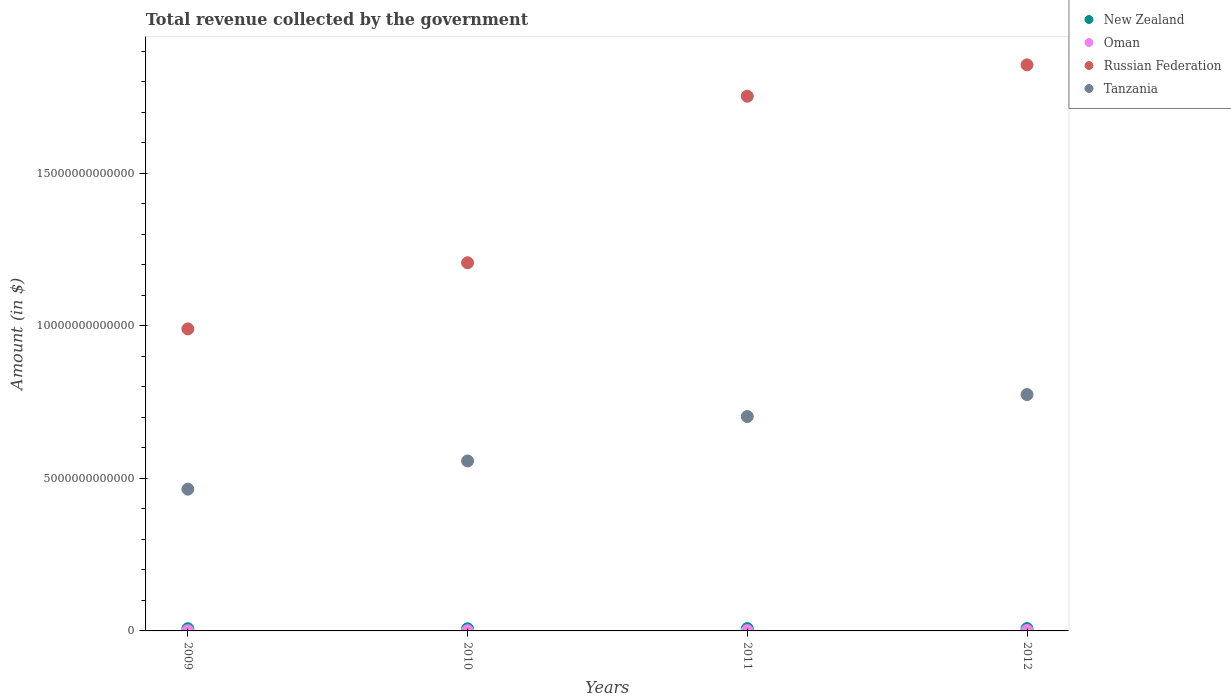What is the total revenue collected by the government in Oman in 2009?
Give a very brief answer. 6.71e+09. Across all years, what is the maximum total revenue collected by the government in Oman?
Give a very brief answer. 1.34e+1. Across all years, what is the minimum total revenue collected by the government in Tanzania?
Keep it short and to the point. 4.65e+12. In which year was the total revenue collected by the government in Oman minimum?
Your answer should be very brief. 2009. What is the total total revenue collected by the government in Oman in the graph?
Your answer should be compact. 3.86e+1. What is the difference between the total revenue collected by the government in Tanzania in 2009 and that in 2010?
Your response must be concise. -9.25e+11. What is the difference between the total revenue collected by the government in Oman in 2011 and the total revenue collected by the government in Russian Federation in 2009?
Keep it short and to the point. -9.89e+12. What is the average total revenue collected by the government in New Zealand per year?
Keep it short and to the point. 7.36e+1. In the year 2011, what is the difference between the total revenue collected by the government in Russian Federation and total revenue collected by the government in Tanzania?
Offer a terse response. 1.05e+13. What is the ratio of the total revenue collected by the government in Russian Federation in 2010 to that in 2011?
Ensure brevity in your answer.  0.69. Is the total revenue collected by the government in Russian Federation in 2011 less than that in 2012?
Provide a short and direct response. Yes. What is the difference between the highest and the second highest total revenue collected by the government in Tanzania?
Your answer should be compact. 7.20e+11. What is the difference between the highest and the lowest total revenue collected by the government in Russian Federation?
Make the answer very short. 8.65e+12. In how many years, is the total revenue collected by the government in New Zealand greater than the average total revenue collected by the government in New Zealand taken over all years?
Your answer should be very brief. 2. Is the sum of the total revenue collected by the government in Russian Federation in 2009 and 2011 greater than the maximum total revenue collected by the government in Oman across all years?
Your answer should be very brief. Yes. Is the total revenue collected by the government in Oman strictly greater than the total revenue collected by the government in Tanzania over the years?
Your answer should be very brief. No. Is the total revenue collected by the government in Tanzania strictly less than the total revenue collected by the government in Russian Federation over the years?
Give a very brief answer. Yes. How many dotlines are there?
Keep it short and to the point. 4. How many years are there in the graph?
Provide a succinct answer. 4. What is the difference between two consecutive major ticks on the Y-axis?
Ensure brevity in your answer.  5.00e+12. Does the graph contain grids?
Your response must be concise. No. What is the title of the graph?
Your answer should be very brief. Total revenue collected by the government. Does "Guinea" appear as one of the legend labels in the graph?
Give a very brief answer. No. What is the label or title of the Y-axis?
Keep it short and to the point. Amount (in $). What is the Amount (in $) in New Zealand in 2009?
Your response must be concise. 7.20e+1. What is the Amount (in $) in Oman in 2009?
Your answer should be compact. 6.71e+09. What is the Amount (in $) in Russian Federation in 2009?
Provide a short and direct response. 9.90e+12. What is the Amount (in $) of Tanzania in 2009?
Your response must be concise. 4.65e+12. What is the Amount (in $) of New Zealand in 2010?
Provide a short and direct response. 6.99e+1. What is the Amount (in $) of Oman in 2010?
Your answer should be compact. 7.87e+09. What is the Amount (in $) in Russian Federation in 2010?
Provide a short and direct response. 1.21e+13. What is the Amount (in $) of Tanzania in 2010?
Your answer should be compact. 5.57e+12. What is the Amount (in $) of New Zealand in 2011?
Give a very brief answer. 7.61e+1. What is the Amount (in $) of Oman in 2011?
Ensure brevity in your answer.  1.06e+1. What is the Amount (in $) in Russian Federation in 2011?
Keep it short and to the point. 1.75e+13. What is the Amount (in $) in Tanzania in 2011?
Offer a terse response. 7.03e+12. What is the Amount (in $) of New Zealand in 2012?
Keep it short and to the point. 7.64e+1. What is the Amount (in $) in Oman in 2012?
Ensure brevity in your answer.  1.34e+1. What is the Amount (in $) of Russian Federation in 2012?
Your response must be concise. 1.85e+13. What is the Amount (in $) in Tanzania in 2012?
Provide a short and direct response. 7.75e+12. Across all years, what is the maximum Amount (in $) of New Zealand?
Your answer should be very brief. 7.64e+1. Across all years, what is the maximum Amount (in $) of Oman?
Give a very brief answer. 1.34e+1. Across all years, what is the maximum Amount (in $) in Russian Federation?
Offer a terse response. 1.85e+13. Across all years, what is the maximum Amount (in $) of Tanzania?
Provide a short and direct response. 7.75e+12. Across all years, what is the minimum Amount (in $) of New Zealand?
Make the answer very short. 6.99e+1. Across all years, what is the minimum Amount (in $) in Oman?
Keep it short and to the point. 6.71e+09. Across all years, what is the minimum Amount (in $) of Russian Federation?
Keep it short and to the point. 9.90e+12. Across all years, what is the minimum Amount (in $) in Tanzania?
Your answer should be very brief. 4.65e+12. What is the total Amount (in $) in New Zealand in the graph?
Your answer should be very brief. 2.94e+11. What is the total Amount (in $) of Oman in the graph?
Your answer should be compact. 3.86e+1. What is the total Amount (in $) of Russian Federation in the graph?
Provide a succinct answer. 5.80e+13. What is the total Amount (in $) in Tanzania in the graph?
Your response must be concise. 2.50e+13. What is the difference between the Amount (in $) in New Zealand in 2009 and that in 2010?
Your response must be concise. 2.05e+09. What is the difference between the Amount (in $) in Oman in 2009 and that in 2010?
Provide a short and direct response. -1.15e+09. What is the difference between the Amount (in $) in Russian Federation in 2009 and that in 2010?
Give a very brief answer. -2.17e+12. What is the difference between the Amount (in $) of Tanzania in 2009 and that in 2010?
Give a very brief answer. -9.25e+11. What is the difference between the Amount (in $) of New Zealand in 2009 and that in 2011?
Your response must be concise. -4.18e+09. What is the difference between the Amount (in $) in Oman in 2009 and that in 2011?
Provide a short and direct response. -3.85e+09. What is the difference between the Amount (in $) of Russian Federation in 2009 and that in 2011?
Provide a succinct answer. -7.62e+12. What is the difference between the Amount (in $) in Tanzania in 2009 and that in 2011?
Your answer should be compact. -2.38e+12. What is the difference between the Amount (in $) in New Zealand in 2009 and that in 2012?
Give a very brief answer. -4.42e+09. What is the difference between the Amount (in $) of Oman in 2009 and that in 2012?
Give a very brief answer. -6.74e+09. What is the difference between the Amount (in $) of Russian Federation in 2009 and that in 2012?
Your answer should be compact. -8.65e+12. What is the difference between the Amount (in $) of Tanzania in 2009 and that in 2012?
Make the answer very short. -3.10e+12. What is the difference between the Amount (in $) in New Zealand in 2010 and that in 2011?
Provide a succinct answer. -6.24e+09. What is the difference between the Amount (in $) in Oman in 2010 and that in 2011?
Provide a succinct answer. -2.70e+09. What is the difference between the Amount (in $) of Russian Federation in 2010 and that in 2011?
Your response must be concise. -5.46e+12. What is the difference between the Amount (in $) in Tanzania in 2010 and that in 2011?
Your answer should be compact. -1.46e+12. What is the difference between the Amount (in $) of New Zealand in 2010 and that in 2012?
Offer a very short reply. -6.47e+09. What is the difference between the Amount (in $) of Oman in 2010 and that in 2012?
Provide a succinct answer. -5.58e+09. What is the difference between the Amount (in $) in Russian Federation in 2010 and that in 2012?
Provide a short and direct response. -6.48e+12. What is the difference between the Amount (in $) of Tanzania in 2010 and that in 2012?
Keep it short and to the point. -2.18e+12. What is the difference between the Amount (in $) in New Zealand in 2011 and that in 2012?
Provide a succinct answer. -2.32e+08. What is the difference between the Amount (in $) in Oman in 2011 and that in 2012?
Provide a short and direct response. -2.88e+09. What is the difference between the Amount (in $) of Russian Federation in 2011 and that in 2012?
Provide a succinct answer. -1.03e+12. What is the difference between the Amount (in $) in Tanzania in 2011 and that in 2012?
Offer a very short reply. -7.20e+11. What is the difference between the Amount (in $) in New Zealand in 2009 and the Amount (in $) in Oman in 2010?
Your answer should be very brief. 6.41e+1. What is the difference between the Amount (in $) of New Zealand in 2009 and the Amount (in $) of Russian Federation in 2010?
Provide a succinct answer. -1.20e+13. What is the difference between the Amount (in $) in New Zealand in 2009 and the Amount (in $) in Tanzania in 2010?
Your response must be concise. -5.50e+12. What is the difference between the Amount (in $) in Oman in 2009 and the Amount (in $) in Russian Federation in 2010?
Offer a terse response. -1.21e+13. What is the difference between the Amount (in $) of Oman in 2009 and the Amount (in $) of Tanzania in 2010?
Your answer should be compact. -5.56e+12. What is the difference between the Amount (in $) in Russian Federation in 2009 and the Amount (in $) in Tanzania in 2010?
Your response must be concise. 4.33e+12. What is the difference between the Amount (in $) of New Zealand in 2009 and the Amount (in $) of Oman in 2011?
Your answer should be compact. 6.14e+1. What is the difference between the Amount (in $) in New Zealand in 2009 and the Amount (in $) in Russian Federation in 2011?
Your answer should be compact. -1.75e+13. What is the difference between the Amount (in $) of New Zealand in 2009 and the Amount (in $) of Tanzania in 2011?
Keep it short and to the point. -6.95e+12. What is the difference between the Amount (in $) of Oman in 2009 and the Amount (in $) of Russian Federation in 2011?
Your answer should be compact. -1.75e+13. What is the difference between the Amount (in $) in Oman in 2009 and the Amount (in $) in Tanzania in 2011?
Make the answer very short. -7.02e+12. What is the difference between the Amount (in $) of Russian Federation in 2009 and the Amount (in $) of Tanzania in 2011?
Keep it short and to the point. 2.87e+12. What is the difference between the Amount (in $) of New Zealand in 2009 and the Amount (in $) of Oman in 2012?
Your response must be concise. 5.85e+1. What is the difference between the Amount (in $) of New Zealand in 2009 and the Amount (in $) of Russian Federation in 2012?
Offer a very short reply. -1.85e+13. What is the difference between the Amount (in $) of New Zealand in 2009 and the Amount (in $) of Tanzania in 2012?
Your answer should be compact. -7.67e+12. What is the difference between the Amount (in $) in Oman in 2009 and the Amount (in $) in Russian Federation in 2012?
Provide a succinct answer. -1.85e+13. What is the difference between the Amount (in $) of Oman in 2009 and the Amount (in $) of Tanzania in 2012?
Keep it short and to the point. -7.74e+12. What is the difference between the Amount (in $) of Russian Federation in 2009 and the Amount (in $) of Tanzania in 2012?
Offer a very short reply. 2.15e+12. What is the difference between the Amount (in $) in New Zealand in 2010 and the Amount (in $) in Oman in 2011?
Your answer should be very brief. 5.93e+1. What is the difference between the Amount (in $) of New Zealand in 2010 and the Amount (in $) of Russian Federation in 2011?
Make the answer very short. -1.75e+13. What is the difference between the Amount (in $) in New Zealand in 2010 and the Amount (in $) in Tanzania in 2011?
Offer a very short reply. -6.96e+12. What is the difference between the Amount (in $) of Oman in 2010 and the Amount (in $) of Russian Federation in 2011?
Keep it short and to the point. -1.75e+13. What is the difference between the Amount (in $) of Oman in 2010 and the Amount (in $) of Tanzania in 2011?
Provide a succinct answer. -7.02e+12. What is the difference between the Amount (in $) of Russian Federation in 2010 and the Amount (in $) of Tanzania in 2011?
Give a very brief answer. 5.04e+12. What is the difference between the Amount (in $) of New Zealand in 2010 and the Amount (in $) of Oman in 2012?
Make the answer very short. 5.64e+1. What is the difference between the Amount (in $) in New Zealand in 2010 and the Amount (in $) in Russian Federation in 2012?
Offer a terse response. -1.85e+13. What is the difference between the Amount (in $) in New Zealand in 2010 and the Amount (in $) in Tanzania in 2012?
Offer a terse response. -7.68e+12. What is the difference between the Amount (in $) of Oman in 2010 and the Amount (in $) of Russian Federation in 2012?
Your response must be concise. -1.85e+13. What is the difference between the Amount (in $) in Oman in 2010 and the Amount (in $) in Tanzania in 2012?
Offer a terse response. -7.74e+12. What is the difference between the Amount (in $) in Russian Federation in 2010 and the Amount (in $) in Tanzania in 2012?
Make the answer very short. 4.32e+12. What is the difference between the Amount (in $) in New Zealand in 2011 and the Amount (in $) in Oman in 2012?
Your answer should be compact. 6.27e+1. What is the difference between the Amount (in $) in New Zealand in 2011 and the Amount (in $) in Russian Federation in 2012?
Make the answer very short. -1.85e+13. What is the difference between the Amount (in $) of New Zealand in 2011 and the Amount (in $) of Tanzania in 2012?
Your answer should be very brief. -7.67e+12. What is the difference between the Amount (in $) in Oman in 2011 and the Amount (in $) in Russian Federation in 2012?
Your answer should be very brief. -1.85e+13. What is the difference between the Amount (in $) in Oman in 2011 and the Amount (in $) in Tanzania in 2012?
Your response must be concise. -7.74e+12. What is the difference between the Amount (in $) in Russian Federation in 2011 and the Amount (in $) in Tanzania in 2012?
Make the answer very short. 9.78e+12. What is the average Amount (in $) in New Zealand per year?
Keep it short and to the point. 7.36e+1. What is the average Amount (in $) in Oman per year?
Provide a succinct answer. 9.65e+09. What is the average Amount (in $) of Russian Federation per year?
Make the answer very short. 1.45e+13. What is the average Amount (in $) in Tanzania per year?
Provide a succinct answer. 6.25e+12. In the year 2009, what is the difference between the Amount (in $) of New Zealand and Amount (in $) of Oman?
Your answer should be compact. 6.52e+1. In the year 2009, what is the difference between the Amount (in $) of New Zealand and Amount (in $) of Russian Federation?
Provide a short and direct response. -9.83e+12. In the year 2009, what is the difference between the Amount (in $) in New Zealand and Amount (in $) in Tanzania?
Your response must be concise. -4.57e+12. In the year 2009, what is the difference between the Amount (in $) of Oman and Amount (in $) of Russian Federation?
Keep it short and to the point. -9.89e+12. In the year 2009, what is the difference between the Amount (in $) of Oman and Amount (in $) of Tanzania?
Your response must be concise. -4.64e+12. In the year 2009, what is the difference between the Amount (in $) in Russian Federation and Amount (in $) in Tanzania?
Your response must be concise. 5.25e+12. In the year 2010, what is the difference between the Amount (in $) in New Zealand and Amount (in $) in Oman?
Your answer should be compact. 6.20e+1. In the year 2010, what is the difference between the Amount (in $) in New Zealand and Amount (in $) in Russian Federation?
Offer a terse response. -1.20e+13. In the year 2010, what is the difference between the Amount (in $) in New Zealand and Amount (in $) in Tanzania?
Your response must be concise. -5.50e+12. In the year 2010, what is the difference between the Amount (in $) of Oman and Amount (in $) of Russian Federation?
Your response must be concise. -1.21e+13. In the year 2010, what is the difference between the Amount (in $) in Oman and Amount (in $) in Tanzania?
Provide a short and direct response. -5.56e+12. In the year 2010, what is the difference between the Amount (in $) of Russian Federation and Amount (in $) of Tanzania?
Provide a short and direct response. 6.49e+12. In the year 2011, what is the difference between the Amount (in $) in New Zealand and Amount (in $) in Oman?
Make the answer very short. 6.56e+1. In the year 2011, what is the difference between the Amount (in $) of New Zealand and Amount (in $) of Russian Federation?
Offer a terse response. -1.74e+13. In the year 2011, what is the difference between the Amount (in $) of New Zealand and Amount (in $) of Tanzania?
Give a very brief answer. -6.95e+12. In the year 2011, what is the difference between the Amount (in $) in Oman and Amount (in $) in Russian Federation?
Your answer should be compact. -1.75e+13. In the year 2011, what is the difference between the Amount (in $) of Oman and Amount (in $) of Tanzania?
Give a very brief answer. -7.02e+12. In the year 2011, what is the difference between the Amount (in $) of Russian Federation and Amount (in $) of Tanzania?
Ensure brevity in your answer.  1.05e+13. In the year 2012, what is the difference between the Amount (in $) in New Zealand and Amount (in $) in Oman?
Give a very brief answer. 6.29e+1. In the year 2012, what is the difference between the Amount (in $) in New Zealand and Amount (in $) in Russian Federation?
Offer a terse response. -1.85e+13. In the year 2012, what is the difference between the Amount (in $) in New Zealand and Amount (in $) in Tanzania?
Offer a very short reply. -7.67e+12. In the year 2012, what is the difference between the Amount (in $) of Oman and Amount (in $) of Russian Federation?
Your response must be concise. -1.85e+13. In the year 2012, what is the difference between the Amount (in $) in Oman and Amount (in $) in Tanzania?
Provide a succinct answer. -7.73e+12. In the year 2012, what is the difference between the Amount (in $) in Russian Federation and Amount (in $) in Tanzania?
Ensure brevity in your answer.  1.08e+13. What is the ratio of the Amount (in $) of New Zealand in 2009 to that in 2010?
Keep it short and to the point. 1.03. What is the ratio of the Amount (in $) of Oman in 2009 to that in 2010?
Provide a succinct answer. 0.85. What is the ratio of the Amount (in $) of Russian Federation in 2009 to that in 2010?
Ensure brevity in your answer.  0.82. What is the ratio of the Amount (in $) in Tanzania in 2009 to that in 2010?
Offer a terse response. 0.83. What is the ratio of the Amount (in $) of New Zealand in 2009 to that in 2011?
Offer a very short reply. 0.94. What is the ratio of the Amount (in $) in Oman in 2009 to that in 2011?
Make the answer very short. 0.64. What is the ratio of the Amount (in $) of Russian Federation in 2009 to that in 2011?
Offer a terse response. 0.56. What is the ratio of the Amount (in $) of Tanzania in 2009 to that in 2011?
Provide a short and direct response. 0.66. What is the ratio of the Amount (in $) in New Zealand in 2009 to that in 2012?
Offer a very short reply. 0.94. What is the ratio of the Amount (in $) in Oman in 2009 to that in 2012?
Provide a succinct answer. 0.5. What is the ratio of the Amount (in $) in Russian Federation in 2009 to that in 2012?
Offer a very short reply. 0.53. What is the ratio of the Amount (in $) of Tanzania in 2009 to that in 2012?
Your answer should be very brief. 0.6. What is the ratio of the Amount (in $) in New Zealand in 2010 to that in 2011?
Keep it short and to the point. 0.92. What is the ratio of the Amount (in $) of Oman in 2010 to that in 2011?
Your answer should be very brief. 0.74. What is the ratio of the Amount (in $) of Russian Federation in 2010 to that in 2011?
Provide a short and direct response. 0.69. What is the ratio of the Amount (in $) of Tanzania in 2010 to that in 2011?
Offer a very short reply. 0.79. What is the ratio of the Amount (in $) of New Zealand in 2010 to that in 2012?
Ensure brevity in your answer.  0.92. What is the ratio of the Amount (in $) in Oman in 2010 to that in 2012?
Your response must be concise. 0.59. What is the ratio of the Amount (in $) in Russian Federation in 2010 to that in 2012?
Offer a very short reply. 0.65. What is the ratio of the Amount (in $) in Tanzania in 2010 to that in 2012?
Make the answer very short. 0.72. What is the ratio of the Amount (in $) in Oman in 2011 to that in 2012?
Offer a very short reply. 0.79. What is the ratio of the Amount (in $) of Russian Federation in 2011 to that in 2012?
Your response must be concise. 0.94. What is the ratio of the Amount (in $) of Tanzania in 2011 to that in 2012?
Provide a succinct answer. 0.91. What is the difference between the highest and the second highest Amount (in $) of New Zealand?
Offer a terse response. 2.32e+08. What is the difference between the highest and the second highest Amount (in $) in Oman?
Make the answer very short. 2.88e+09. What is the difference between the highest and the second highest Amount (in $) in Russian Federation?
Keep it short and to the point. 1.03e+12. What is the difference between the highest and the second highest Amount (in $) in Tanzania?
Your answer should be very brief. 7.20e+11. What is the difference between the highest and the lowest Amount (in $) of New Zealand?
Provide a short and direct response. 6.47e+09. What is the difference between the highest and the lowest Amount (in $) of Oman?
Provide a succinct answer. 6.74e+09. What is the difference between the highest and the lowest Amount (in $) in Russian Federation?
Make the answer very short. 8.65e+12. What is the difference between the highest and the lowest Amount (in $) in Tanzania?
Keep it short and to the point. 3.10e+12. 